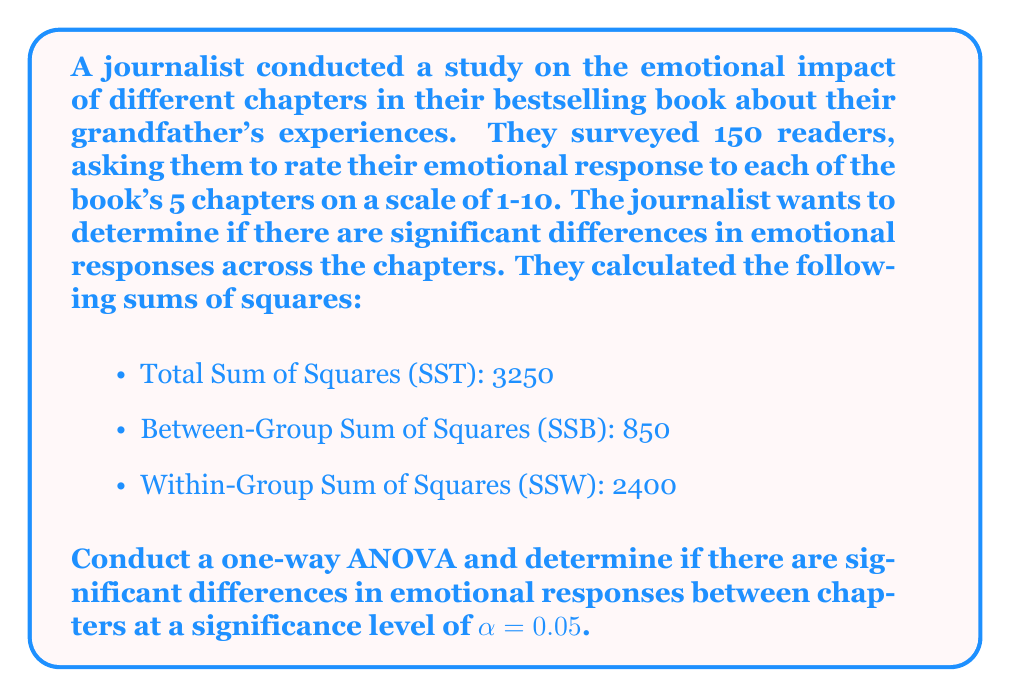Can you answer this question? To conduct a one-way ANOVA, we need to follow these steps:

1. Calculate the degrees of freedom:
   - Between-group df: $df_B = k - 1$, where k is the number of groups (chapters)
   - Within-group df: $df_W = N - k$, where N is the total number of observations
   - Total df: $df_T = N - 1$

   $df_B = 5 - 1 = 4$
   $df_W = 150 - 5 = 145$
   $df_T = 150 - 1 = 149$

2. Calculate the Mean Square values:
   $MS_B = \frac{SSB}{df_B} = \frac{850}{4} = 212.5$
   $MS_W = \frac{SSW}{df_W} = \frac{2400}{145} \approx 16.55$

3. Calculate the F-statistic:
   $F = \frac{MS_B}{MS_W} = \frac{212.5}{16.55} \approx 12.84$

4. Find the critical F-value:
   With $\alpha = 0.05$, $df_B = 4$, and $df_W = 145$, we can look up the critical F-value in an F-distribution table or use a calculator. The critical F-value is approximately 2.43.

5. Compare the calculated F-statistic to the critical F-value:
   Since $12.84 > 2.43$, we reject the null hypothesis.

6. Calculate the p-value:
   Using an F-distribution calculator with $df_B = 4$ and $df_W = 145$, we find that the p-value for $F = 12.84$ is approximately $1.39 \times 10^{-8}$, which is much smaller than $\alpha = 0.05$.
Answer: Reject the null hypothesis. There are significant differences in emotional responses between chapters (F(4, 145) ≈ 12.84, p < 0.05). 